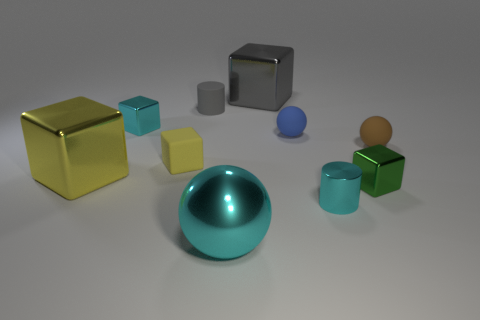How many things are either tiny cyan things behind the small blue ball or yellow things that are on the left side of the tiny brown matte ball?
Your answer should be very brief. 3. Are the yellow thing on the left side of the cyan metallic cube and the big cube that is behind the blue rubber thing made of the same material?
Provide a succinct answer. Yes. What shape is the cyan object behind the matte sphere behind the brown thing?
Provide a succinct answer. Cube. Is there anything else that is the same color as the metal ball?
Provide a succinct answer. Yes. There is a cyan thing that is behind the big shiny cube in front of the brown matte thing; are there any big gray objects behind it?
Provide a succinct answer. Yes. Is the color of the large metallic object to the right of the big cyan sphere the same as the small cylinder that is behind the brown rubber thing?
Offer a terse response. Yes. There is a cyan object that is the same size as the cyan cylinder; what is it made of?
Keep it short and to the point. Metal. There is a cyan metallic object behind the large object that is on the left side of the tiny cylinder behind the yellow matte object; what size is it?
Keep it short and to the point. Small. How many other things are made of the same material as the tiny cyan cube?
Give a very brief answer. 5. How big is the cube that is to the right of the blue matte sphere?
Your answer should be compact. Small. 